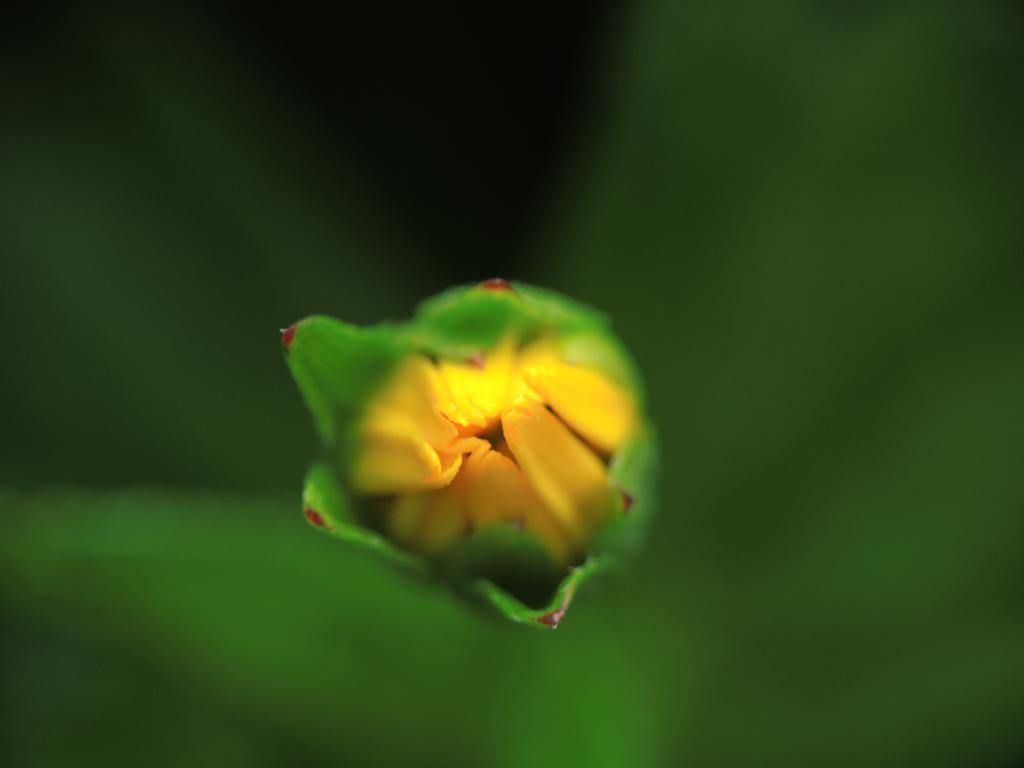Please provide a concise description of this image. In this picture there is a flower in the center and the background is blurry. 